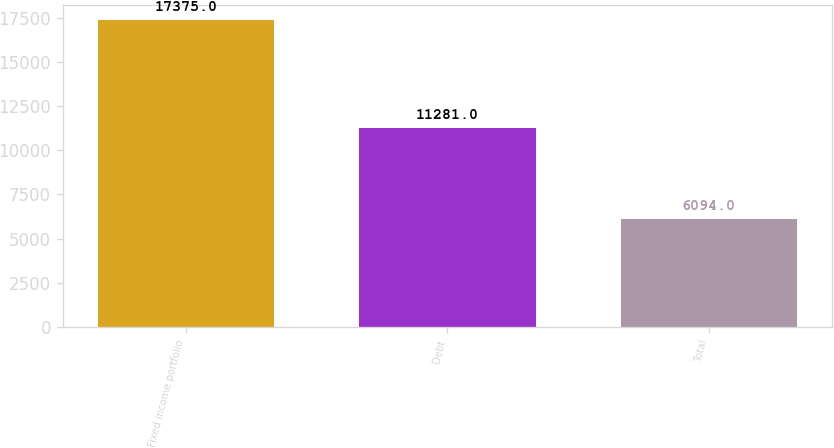Convert chart to OTSL. <chart><loc_0><loc_0><loc_500><loc_500><bar_chart><fcel>Fixed income portfolio<fcel>Debt<fcel>Total<nl><fcel>17375<fcel>11281<fcel>6094<nl></chart> 